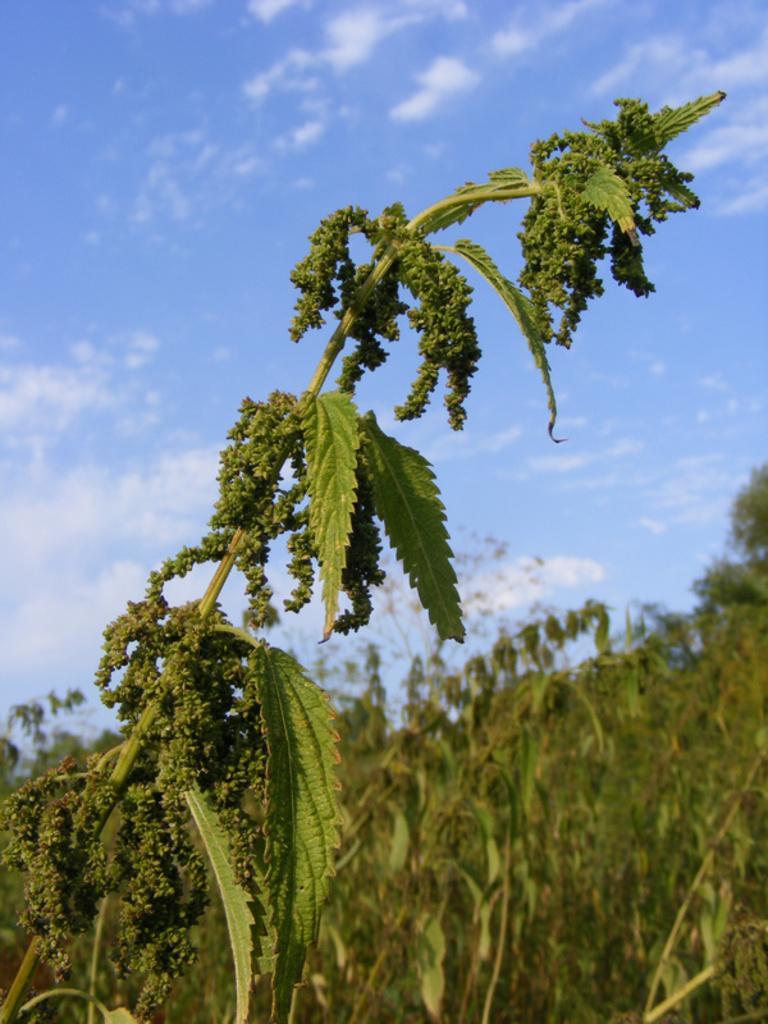In one or two sentences, can you explain what this image depicts? In this picture I can see there is a plant here and it has some leaves and there are trees in the backdrop. 